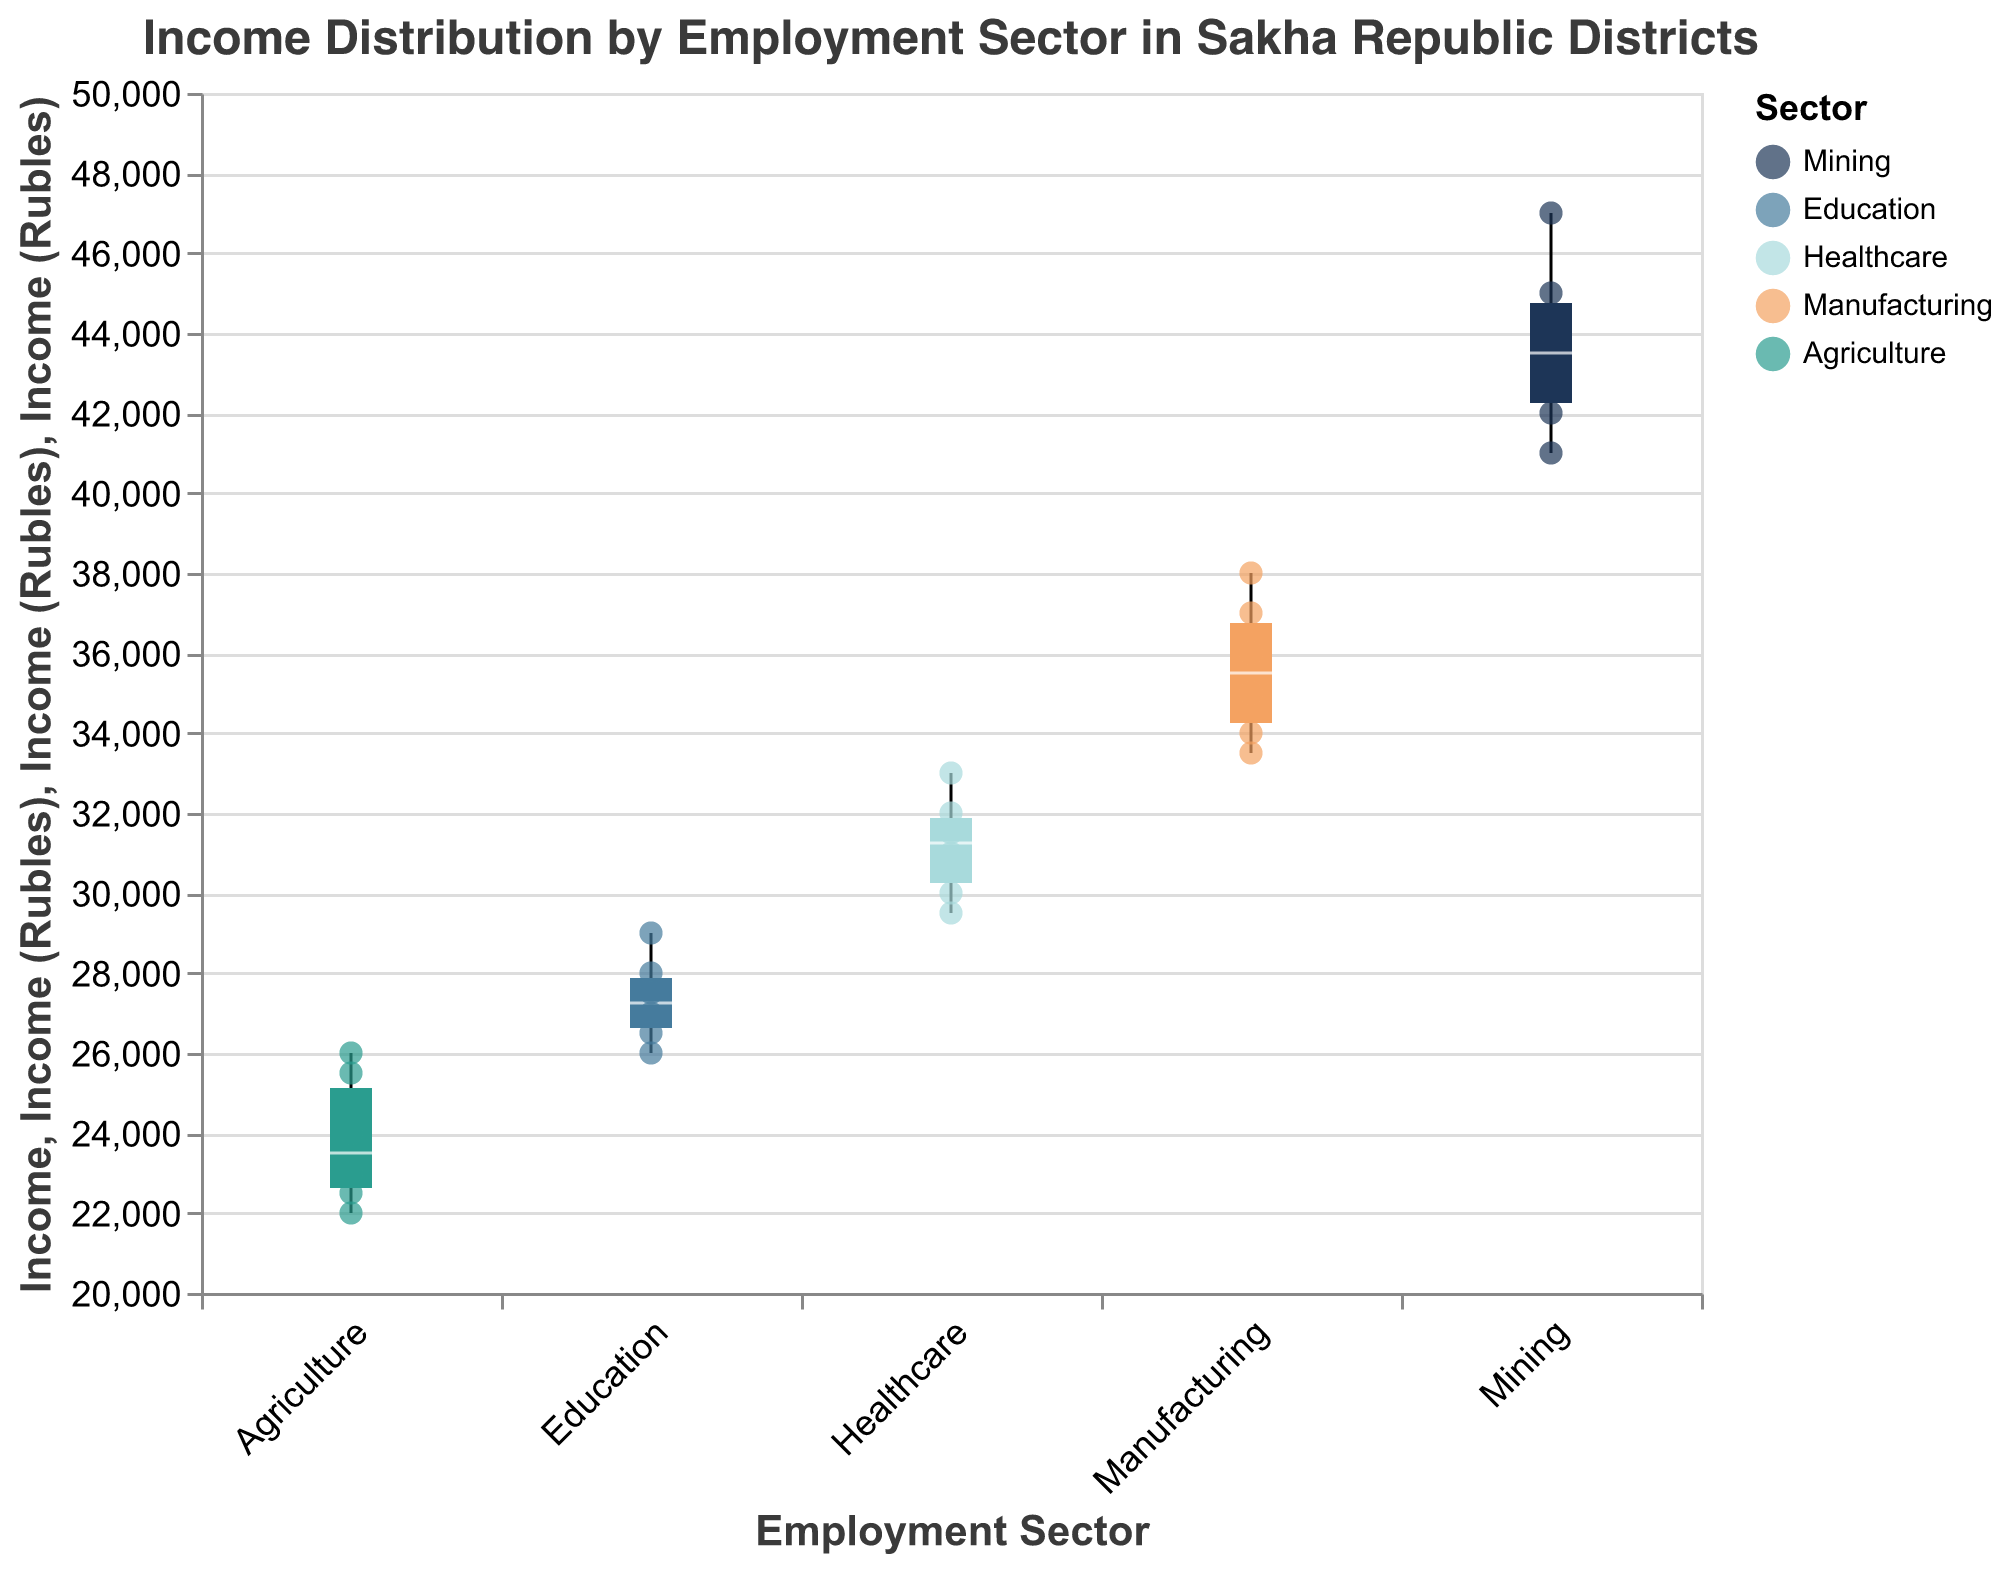How many employment sectors are represented in the figure? The x-axis lists all the employment sectors represented in the figure. By observing, we see the sectors Mining, Education, Healthcare, Manufacturing, and Agriculture.
Answer: Five What is the employment sector with the highest median income? The median incomes are shown by the line inside each box in the plot. The highest median line is in the Mining sector.
Answer: Mining Which district has the lowest reported income in the Healthcare sector? By looking at the scatter points for the Healthcare sector, we can see each district's income. The lowest scatter point in Healthcare corresponds to Neryungri with an income of 30,000 Rubles.
Answer: Neryungri What is the range of incomes in the Agriculture sector? The range is determined by the minimum and maximum values in the box plot. For Agriculture, the income ranges from 22,000 to 26,000 Rubles.
Answer: 22,000 to 26,000 Rubles Does any employment sector have reported incomes that exceed 45,000 Rubles? Observing the scatter points, we see the Mining sector has incomes such as 44,000 Rubles in Neryungri and 47,000 Rubles in Mirny, indicating that Mining has incomes above 45,000 Rubles.
Answer: Yes, the Mining sector Comparing the median incomes, which sector does better, Manufacturing or Education? The median incomes of each sector are represented by the middle line of each box. Manufacturing has a higher median line compared to Education.
Answer: Manufacturing Which district has the highest reported income in the Mining sector? By looking at the scatter points under Mining, Mirny has the highest reported income of 47,000 Rubles.
Answer: Mirny What are the median incomes for Education and Manufacturing sectors? The median line inside each boxplot for the Education and Manufacturing sectors shows 27,500 Rubles and 35,000 Rubles respectively.
Answer: Education: 27,500 Rubles, Manufacturing: 35,000 Rubles 